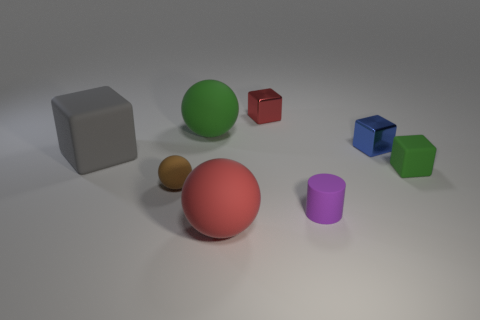Subtract 1 cubes. How many cubes are left? 3 Subtract all yellow blocks. Subtract all yellow cylinders. How many blocks are left? 4 Add 1 large rubber spheres. How many objects exist? 9 Subtract all balls. How many objects are left? 5 Add 6 small purple cylinders. How many small purple cylinders exist? 7 Subtract 0 red cylinders. How many objects are left? 8 Subtract all gray rubber objects. Subtract all green matte cubes. How many objects are left? 6 Add 1 cubes. How many cubes are left? 5 